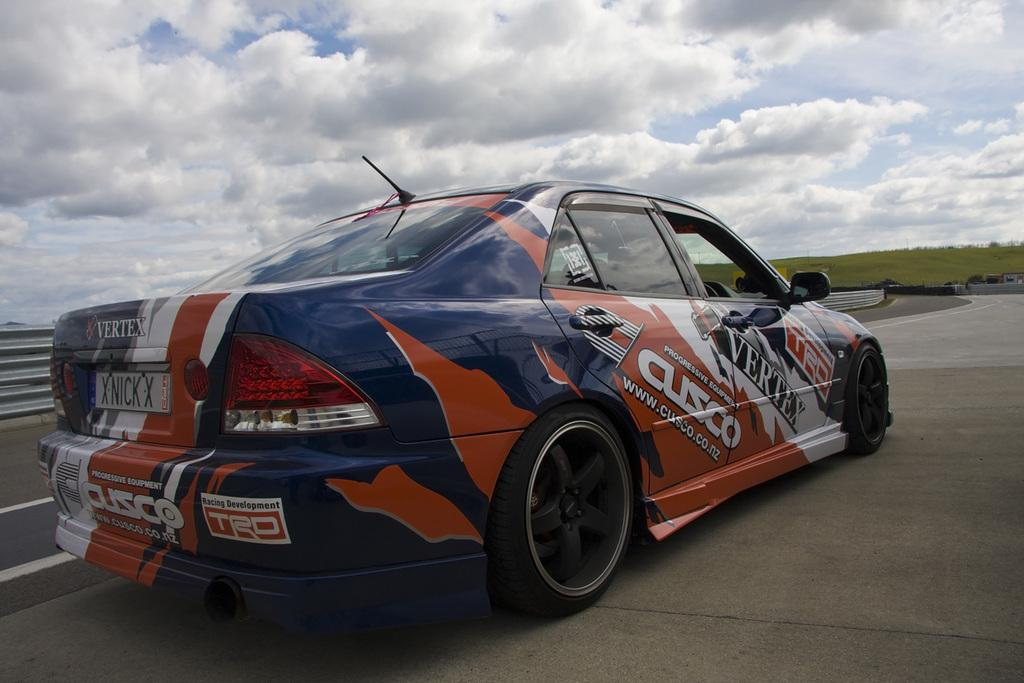What is the main subject in the image? There is a vehicle in the image. What is the setting of the image? There is a road and ground with grass visible in the image. Can you describe the object on the left side of the image? The object on the left side of the image is not specified in the facts, so we cannot describe it. What is visible in the sky in the image? The sky is visible in the image, and clouds are present. What type of knee injury can be seen in the image? There is no knee injury present in the image; it features a vehicle, road, ground with grass, and sky. How many stalks of celery are visible in the image? There is no celery present in the image. 